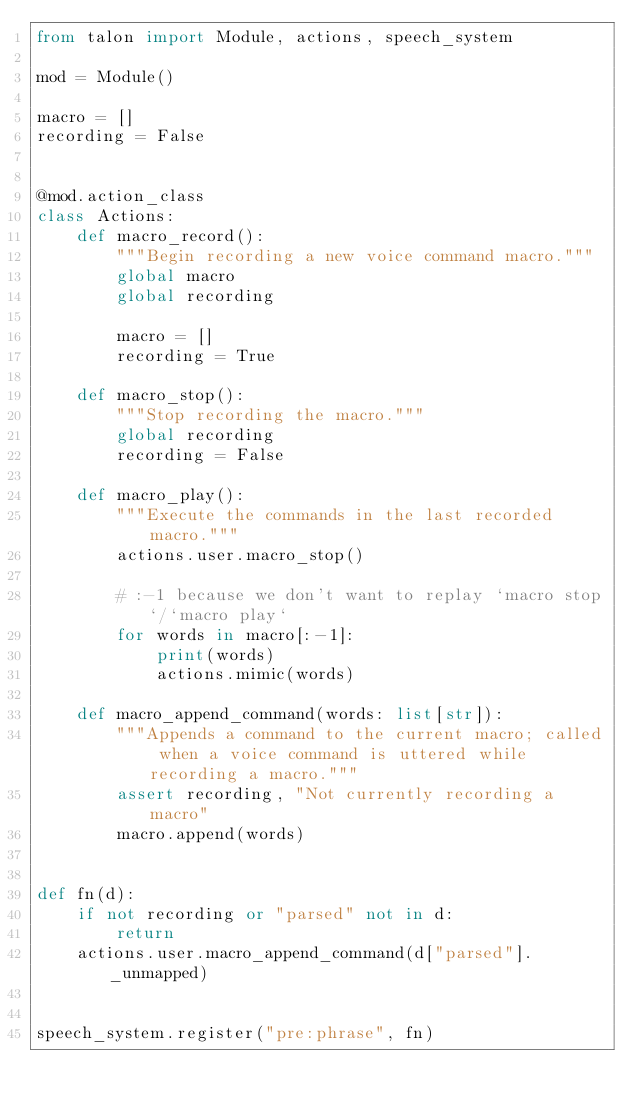Convert code to text. <code><loc_0><loc_0><loc_500><loc_500><_Python_>from talon import Module, actions, speech_system

mod = Module()

macro = []
recording = False


@mod.action_class
class Actions:
    def macro_record():
        """Begin recording a new voice command macro."""
        global macro
        global recording

        macro = []
        recording = True

    def macro_stop():
        """Stop recording the macro."""
        global recording
        recording = False

    def macro_play():
        """Execute the commands in the last recorded macro."""
        actions.user.macro_stop()

        # :-1 because we don't want to replay `macro stop`/`macro play`
        for words in macro[:-1]:
            print(words)
            actions.mimic(words)

    def macro_append_command(words: list[str]):
        """Appends a command to the current macro; called when a voice command is uttered while recording a macro."""
        assert recording, "Not currently recording a macro"
        macro.append(words)


def fn(d):
    if not recording or "parsed" not in d:
        return
    actions.user.macro_append_command(d["parsed"]._unmapped)


speech_system.register("pre:phrase", fn)
</code> 